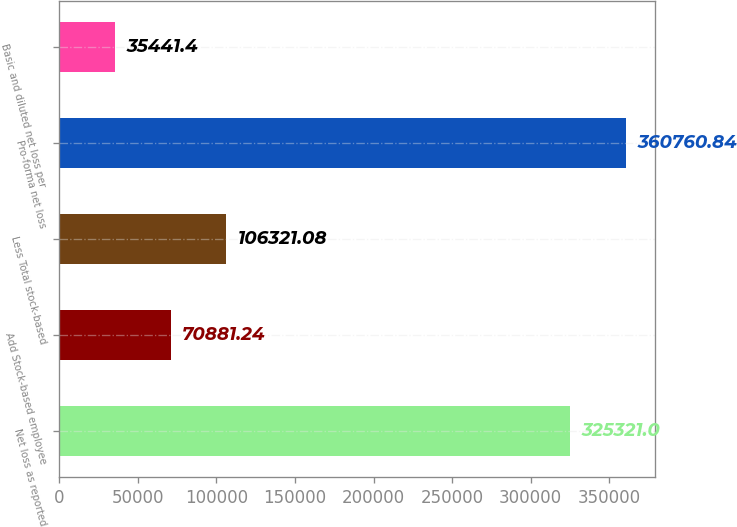<chart> <loc_0><loc_0><loc_500><loc_500><bar_chart><fcel>Net loss as reported<fcel>Add Stock-based employee<fcel>Less Total stock-based<fcel>Pro-forma net loss<fcel>Basic and diluted net loss per<nl><fcel>325321<fcel>70881.2<fcel>106321<fcel>360761<fcel>35441.4<nl></chart> 